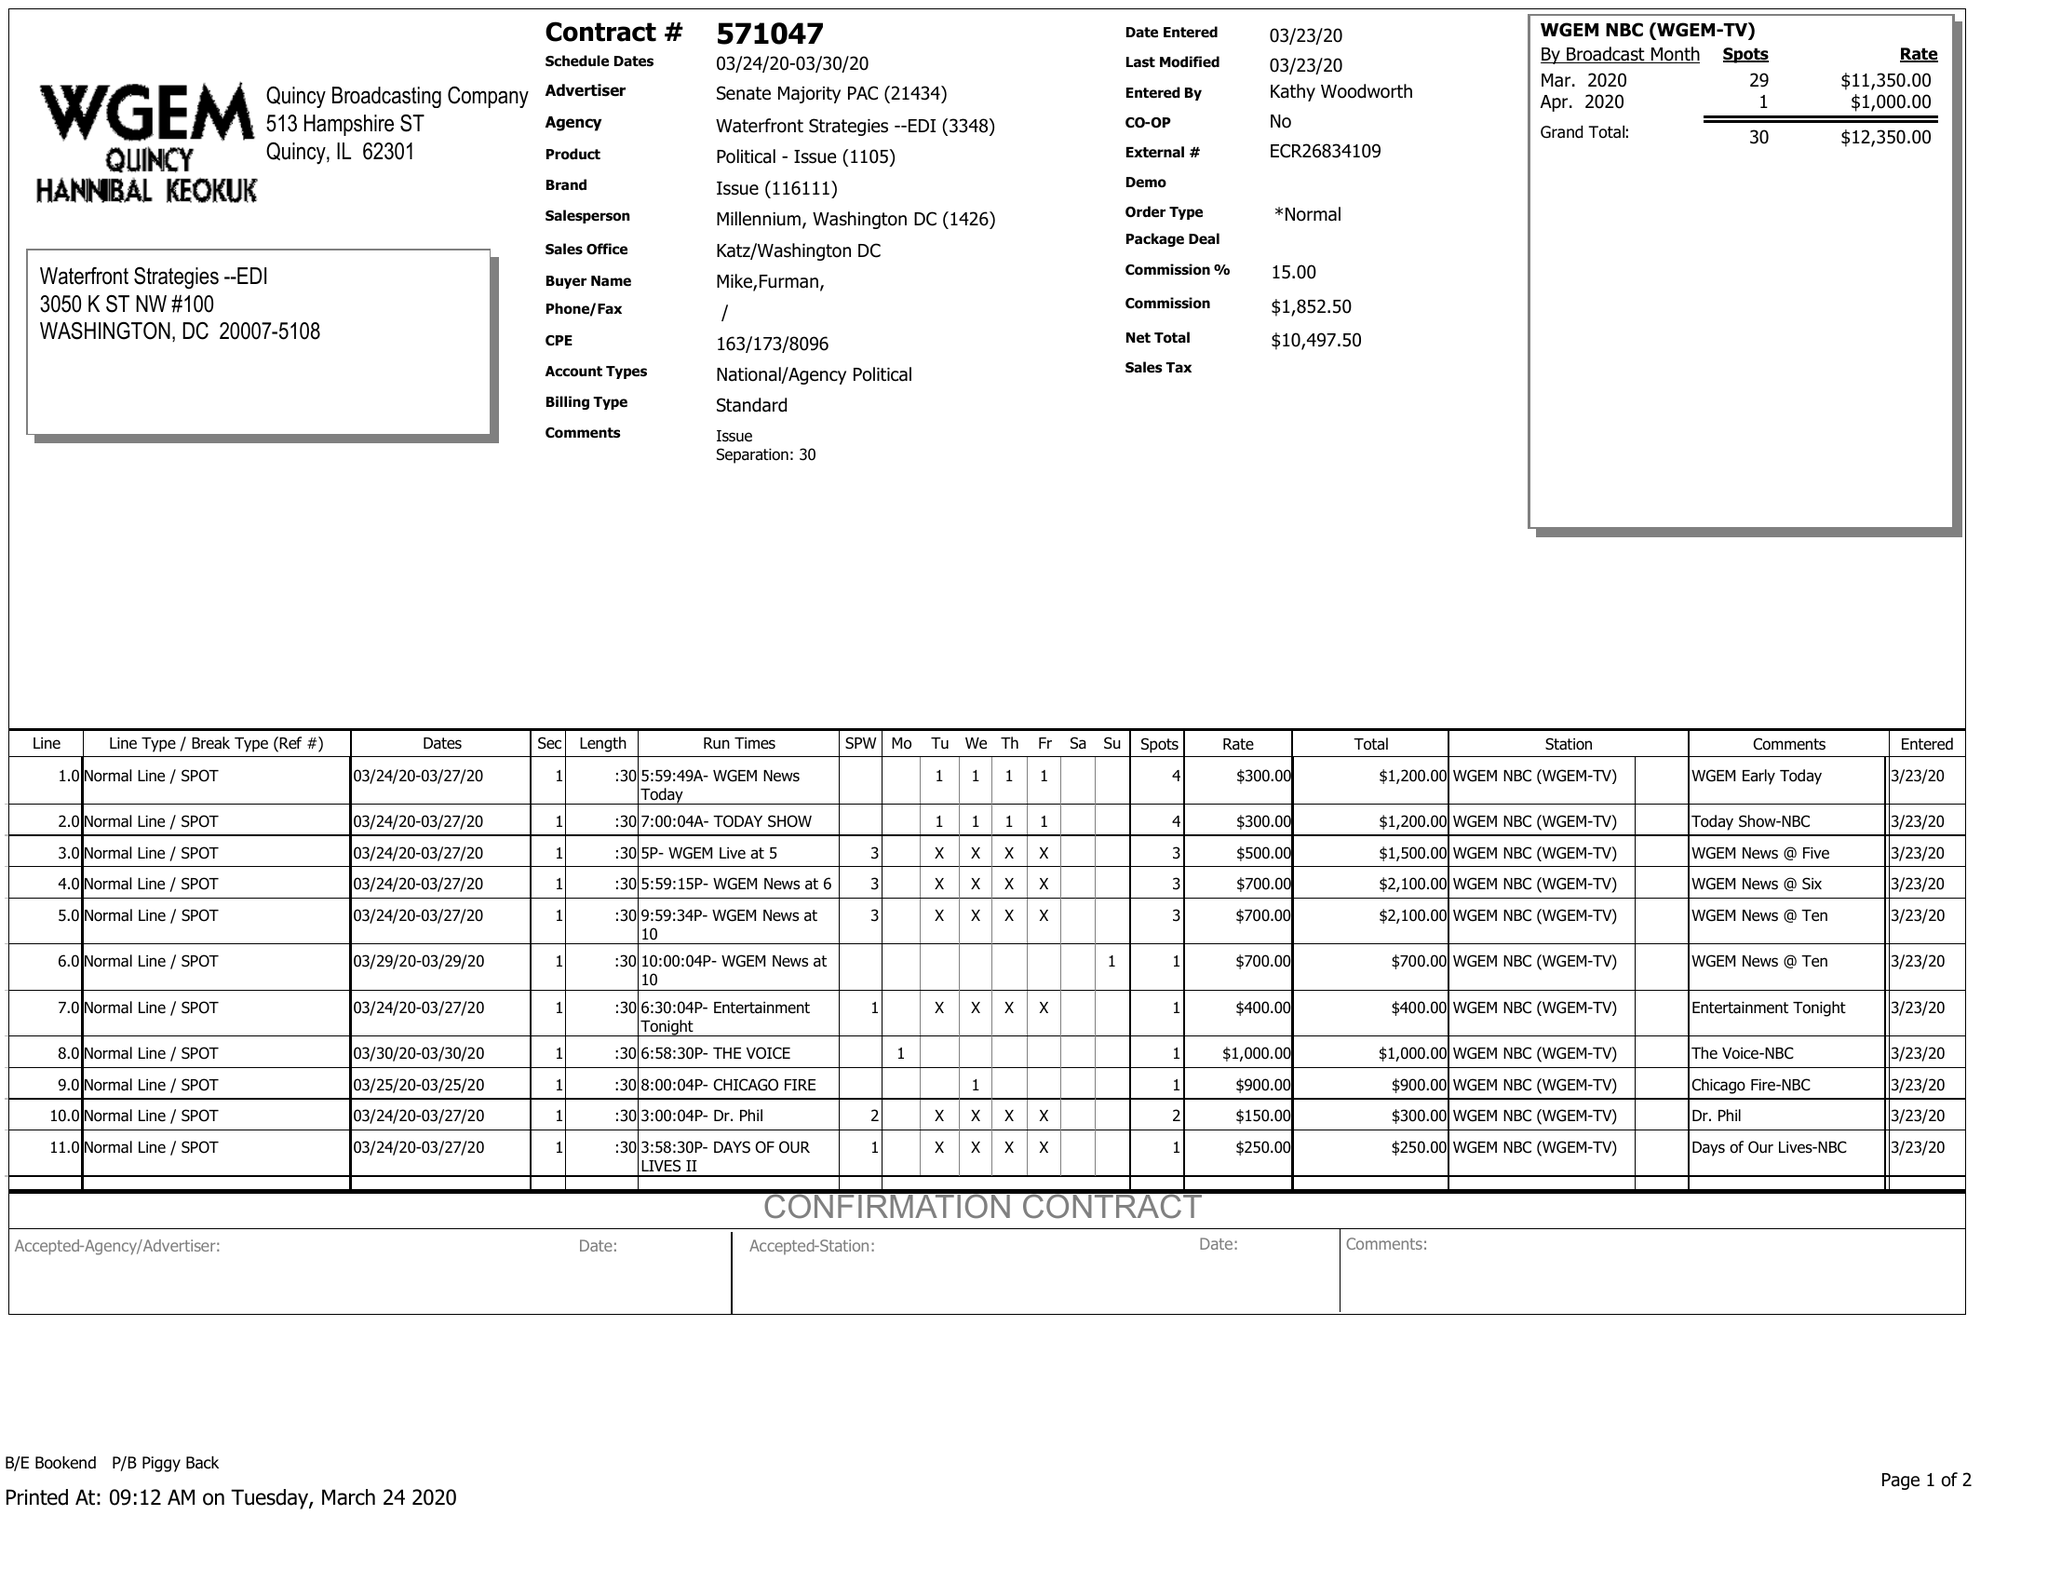What is the value for the flight_to?
Answer the question using a single word or phrase. 03/30/20 